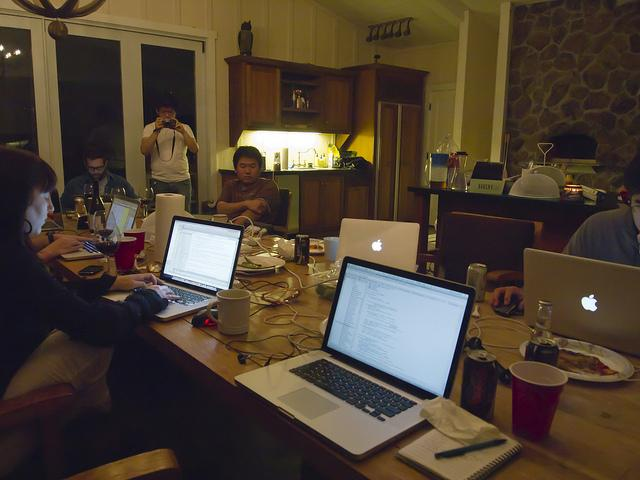What type of animal can be seen on top of the shelf near the back doors? owl 